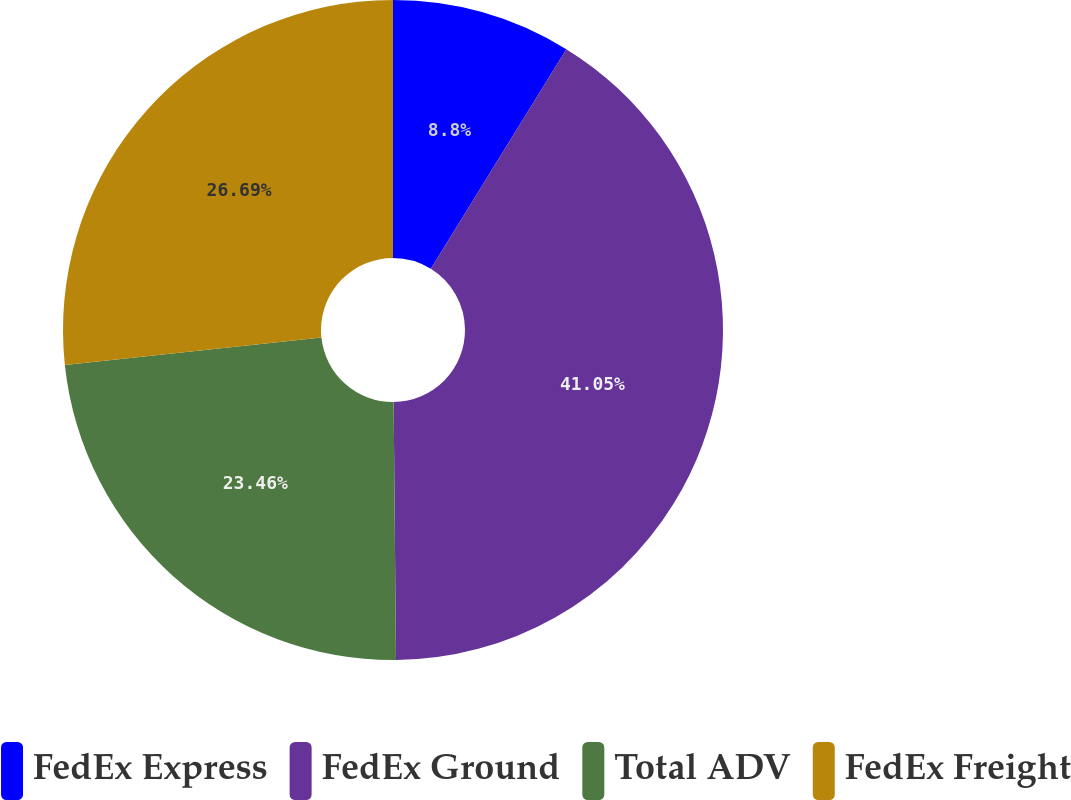Convert chart. <chart><loc_0><loc_0><loc_500><loc_500><pie_chart><fcel>FedEx Express<fcel>FedEx Ground<fcel>Total ADV<fcel>FedEx Freight<nl><fcel>8.8%<fcel>41.06%<fcel>23.46%<fcel>26.69%<nl></chart> 